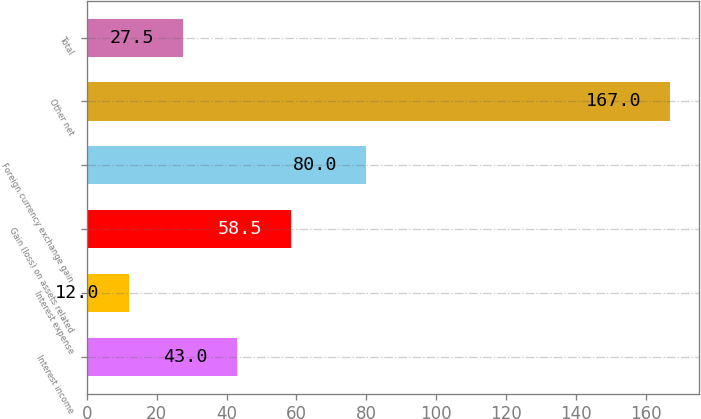Convert chart to OTSL. <chart><loc_0><loc_0><loc_500><loc_500><bar_chart><fcel>Interest income<fcel>Interest expense<fcel>Gain (loss) on assets related<fcel>Foreign currency exchange gain<fcel>Other net<fcel>Total<nl><fcel>43<fcel>12<fcel>58.5<fcel>80<fcel>167<fcel>27.5<nl></chart> 